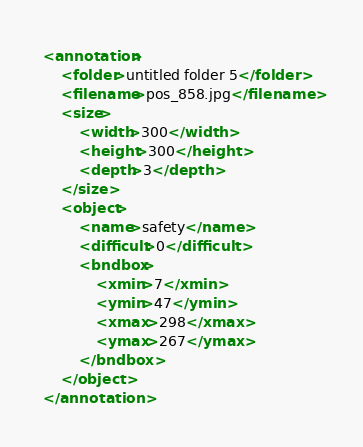Convert code to text. <code><loc_0><loc_0><loc_500><loc_500><_XML_><annotation>
    <folder>untitled folder 5</folder>
    <filename>pos_858.jpg</filename>
    <size>
        <width>300</width>
        <height>300</height>
        <depth>3</depth>
    </size>
    <object>
        <name>safety</name>
        <difficult>0</difficult>
        <bndbox>
            <xmin>7</xmin>
            <ymin>47</ymin>
            <xmax>298</xmax>
            <ymax>267</ymax>
        </bndbox>
    </object>
</annotation></code> 